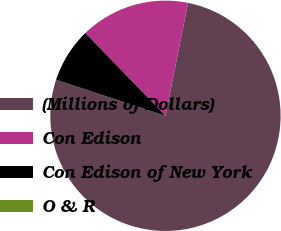Convert chart. <chart><loc_0><loc_0><loc_500><loc_500><pie_chart><fcel>(Millions of Dollars)<fcel>Con Edison<fcel>Con Edison of New York<fcel>O & R<nl><fcel>76.92%<fcel>15.38%<fcel>7.69%<fcel>0.0%<nl></chart> 